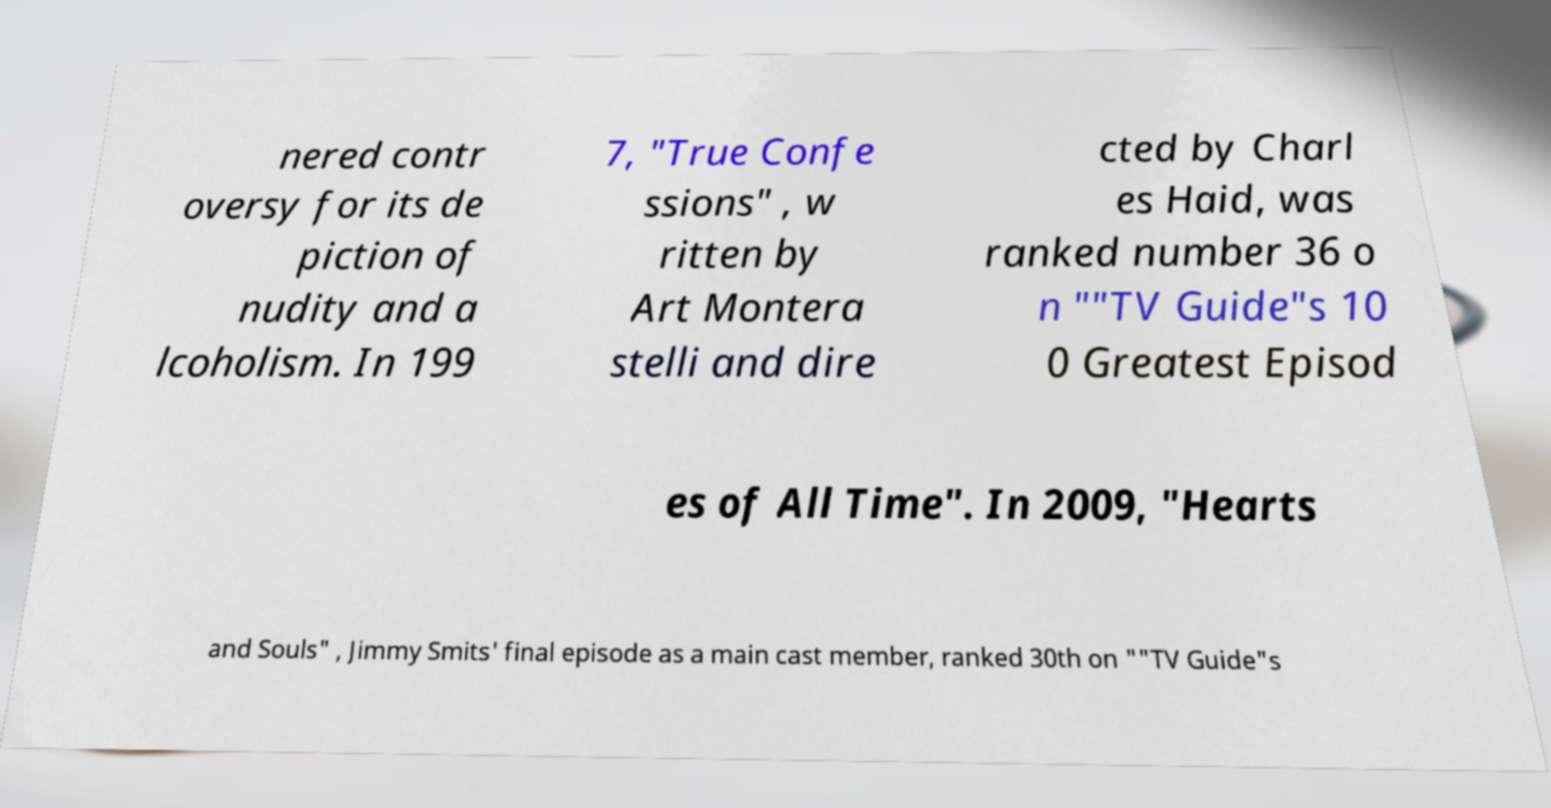Could you assist in decoding the text presented in this image and type it out clearly? nered contr oversy for its de piction of nudity and a lcoholism. In 199 7, "True Confe ssions" , w ritten by Art Montera stelli and dire cted by Charl es Haid, was ranked number 36 o n ""TV Guide"s 10 0 Greatest Episod es of All Time". In 2009, "Hearts and Souls" , Jimmy Smits' final episode as a main cast member, ranked 30th on ""TV Guide"s 